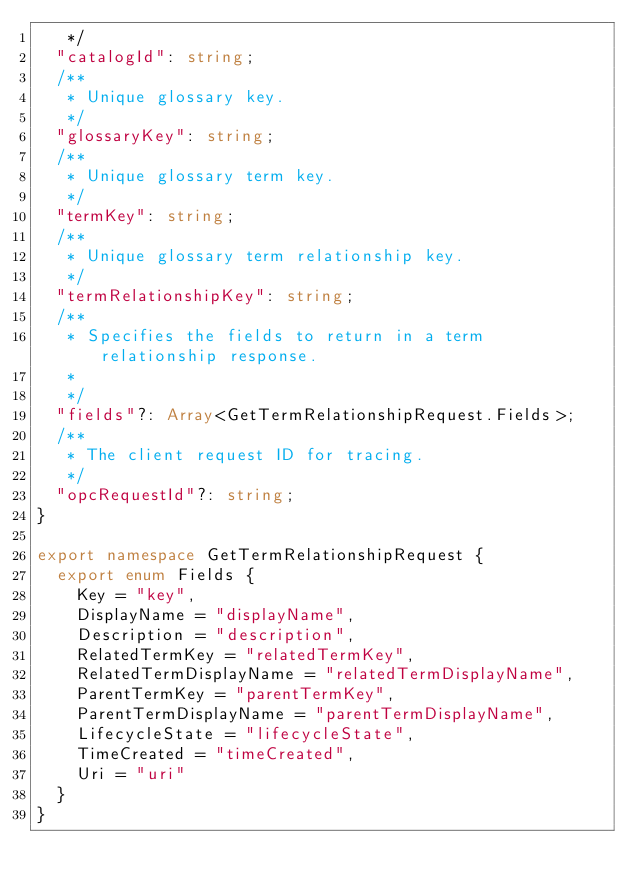Convert code to text. <code><loc_0><loc_0><loc_500><loc_500><_TypeScript_>   */
  "catalogId": string;
  /**
   * Unique glossary key.
   */
  "glossaryKey": string;
  /**
   * Unique glossary term key.
   */
  "termKey": string;
  /**
   * Unique glossary term relationship key.
   */
  "termRelationshipKey": string;
  /**
   * Specifies the fields to return in a term relationship response.
   *
   */
  "fields"?: Array<GetTermRelationshipRequest.Fields>;
  /**
   * The client request ID for tracing.
   */
  "opcRequestId"?: string;
}

export namespace GetTermRelationshipRequest {
  export enum Fields {
    Key = "key",
    DisplayName = "displayName",
    Description = "description",
    RelatedTermKey = "relatedTermKey",
    RelatedTermDisplayName = "relatedTermDisplayName",
    ParentTermKey = "parentTermKey",
    ParentTermDisplayName = "parentTermDisplayName",
    LifecycleState = "lifecycleState",
    TimeCreated = "timeCreated",
    Uri = "uri"
  }
}
</code> 